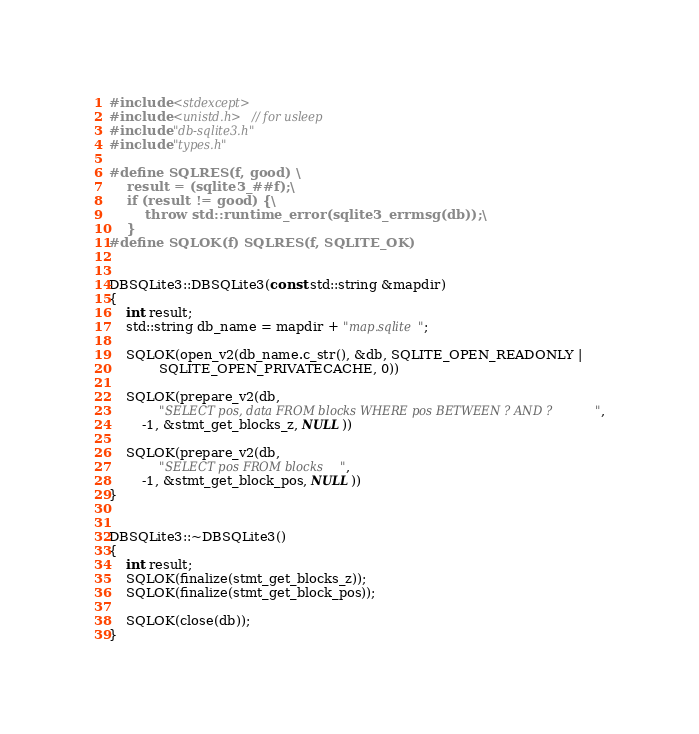Convert code to text. <code><loc_0><loc_0><loc_500><loc_500><_C++_>#include <stdexcept>
#include <unistd.h> // for usleep
#include "db-sqlite3.h"
#include "types.h"

#define SQLRES(f, good) \
	result = (sqlite3_##f);\
	if (result != good) {\
		throw std::runtime_error(sqlite3_errmsg(db));\
	}
#define SQLOK(f) SQLRES(f, SQLITE_OK)


DBSQLite3::DBSQLite3(const std::string &mapdir)
{
	int result;
	std::string db_name = mapdir + "map.sqlite";

	SQLOK(open_v2(db_name.c_str(), &db, SQLITE_OPEN_READONLY |
			SQLITE_OPEN_PRIVATECACHE, 0))

	SQLOK(prepare_v2(db,
			"SELECT pos, data FROM blocks WHERE pos BETWEEN ? AND ?",
		-1, &stmt_get_blocks_z, NULL))

	SQLOK(prepare_v2(db,
			"SELECT pos FROM blocks",
		-1, &stmt_get_block_pos, NULL))
}


DBSQLite3::~DBSQLite3()
{
	int result;
	SQLOK(finalize(stmt_get_blocks_z));
	SQLOK(finalize(stmt_get_block_pos));

	SQLOK(close(db));
}
</code> 